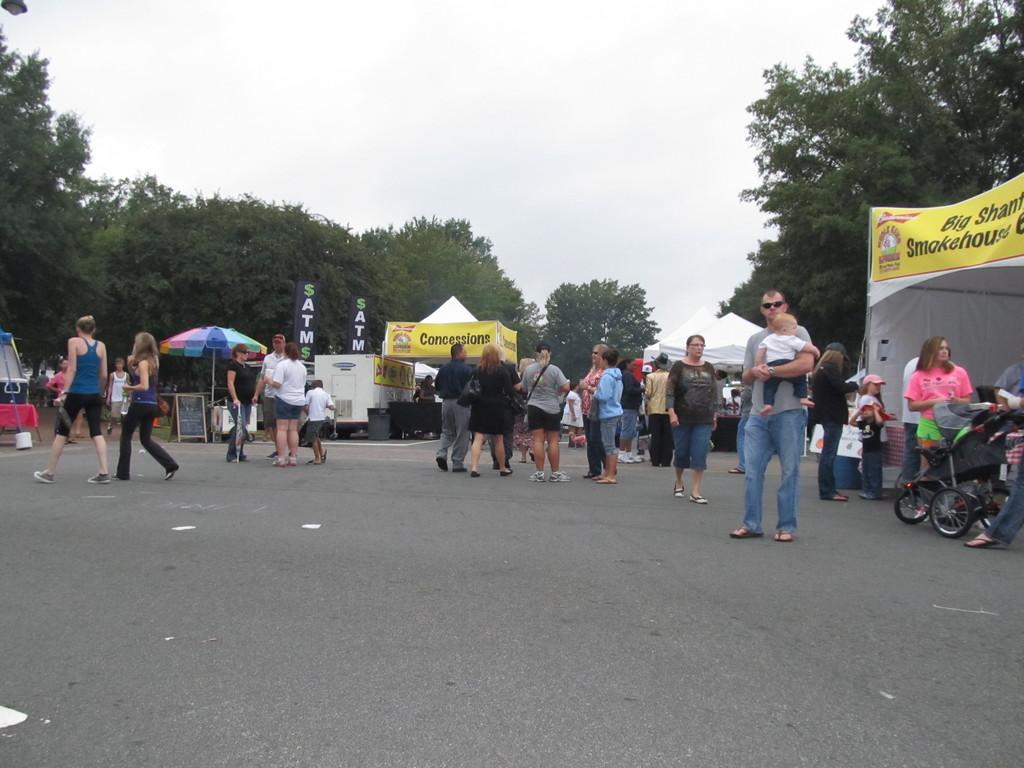Can you describe this image briefly? In this picture I can see group of people standing, there are stalls, there is an umbrella, there are banners, there are canopy tents, there are trees, and in the background there is the sky. 